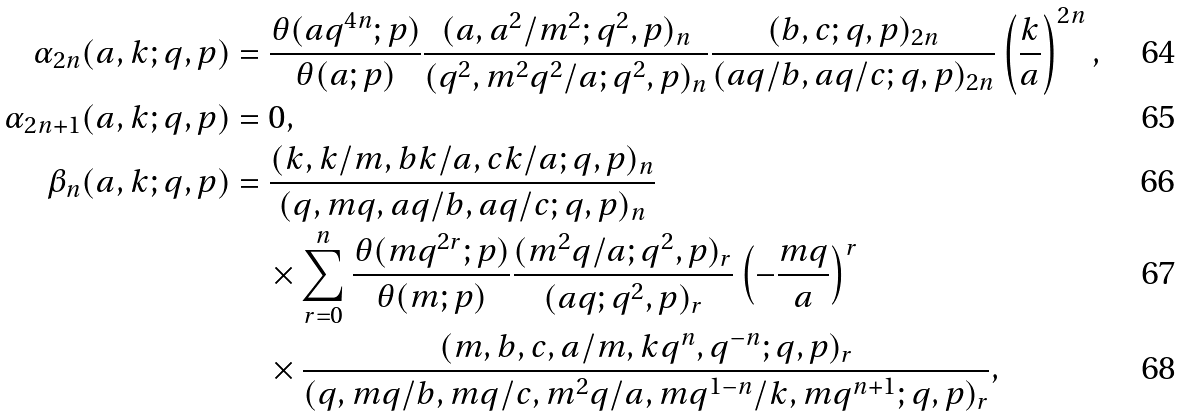<formula> <loc_0><loc_0><loc_500><loc_500>\alpha _ { 2 n } ( a , k ; q , p ) & = \frac { \theta ( a q ^ { 4 n } ; p ) } { \theta ( a ; p ) } \frac { ( a , a ^ { 2 } / m ^ { 2 } ; q ^ { 2 } , p ) _ { n } } { ( q ^ { 2 } , m ^ { 2 } q ^ { 2 } / a ; q ^ { 2 } , p ) _ { n } } \frac { ( b , c ; q , p ) _ { 2 n } } { ( a q / b , a q / c ; q , p ) _ { 2 n } } \left ( \frac { k } { a } \right ) ^ { 2 n } , \\ \alpha _ { 2 n + 1 } ( a , k ; q , p ) & = 0 , \\ \beta _ { n } ( a , k ; q , p ) & = \frac { ( k , k / m , b k / a , c k / a ; q , p ) _ { n } } { ( q , m q , a q / b , a q / c ; q , p ) _ { n } } \\ & \quad \times \sum _ { r = 0 } ^ { n } \frac { \theta ( m q ^ { 2 r } ; p ) } { \theta ( m ; p ) } \frac { ( m ^ { 2 } q / a ; q ^ { 2 } , p ) _ { r } } { ( a q ; q ^ { 2 } , p ) _ { r } } \left ( - \frac { m q } { a } \right ) ^ { r } \\ & \quad \times \frac { ( m , b , c , a / m , k q ^ { n } , q ^ { - n } ; q , p ) _ { r } } { ( q , m q / b , m q / c , m ^ { 2 } q / a , m q ^ { 1 - n } / k , m q ^ { n + 1 } ; q , p ) _ { r } } ,</formula> 